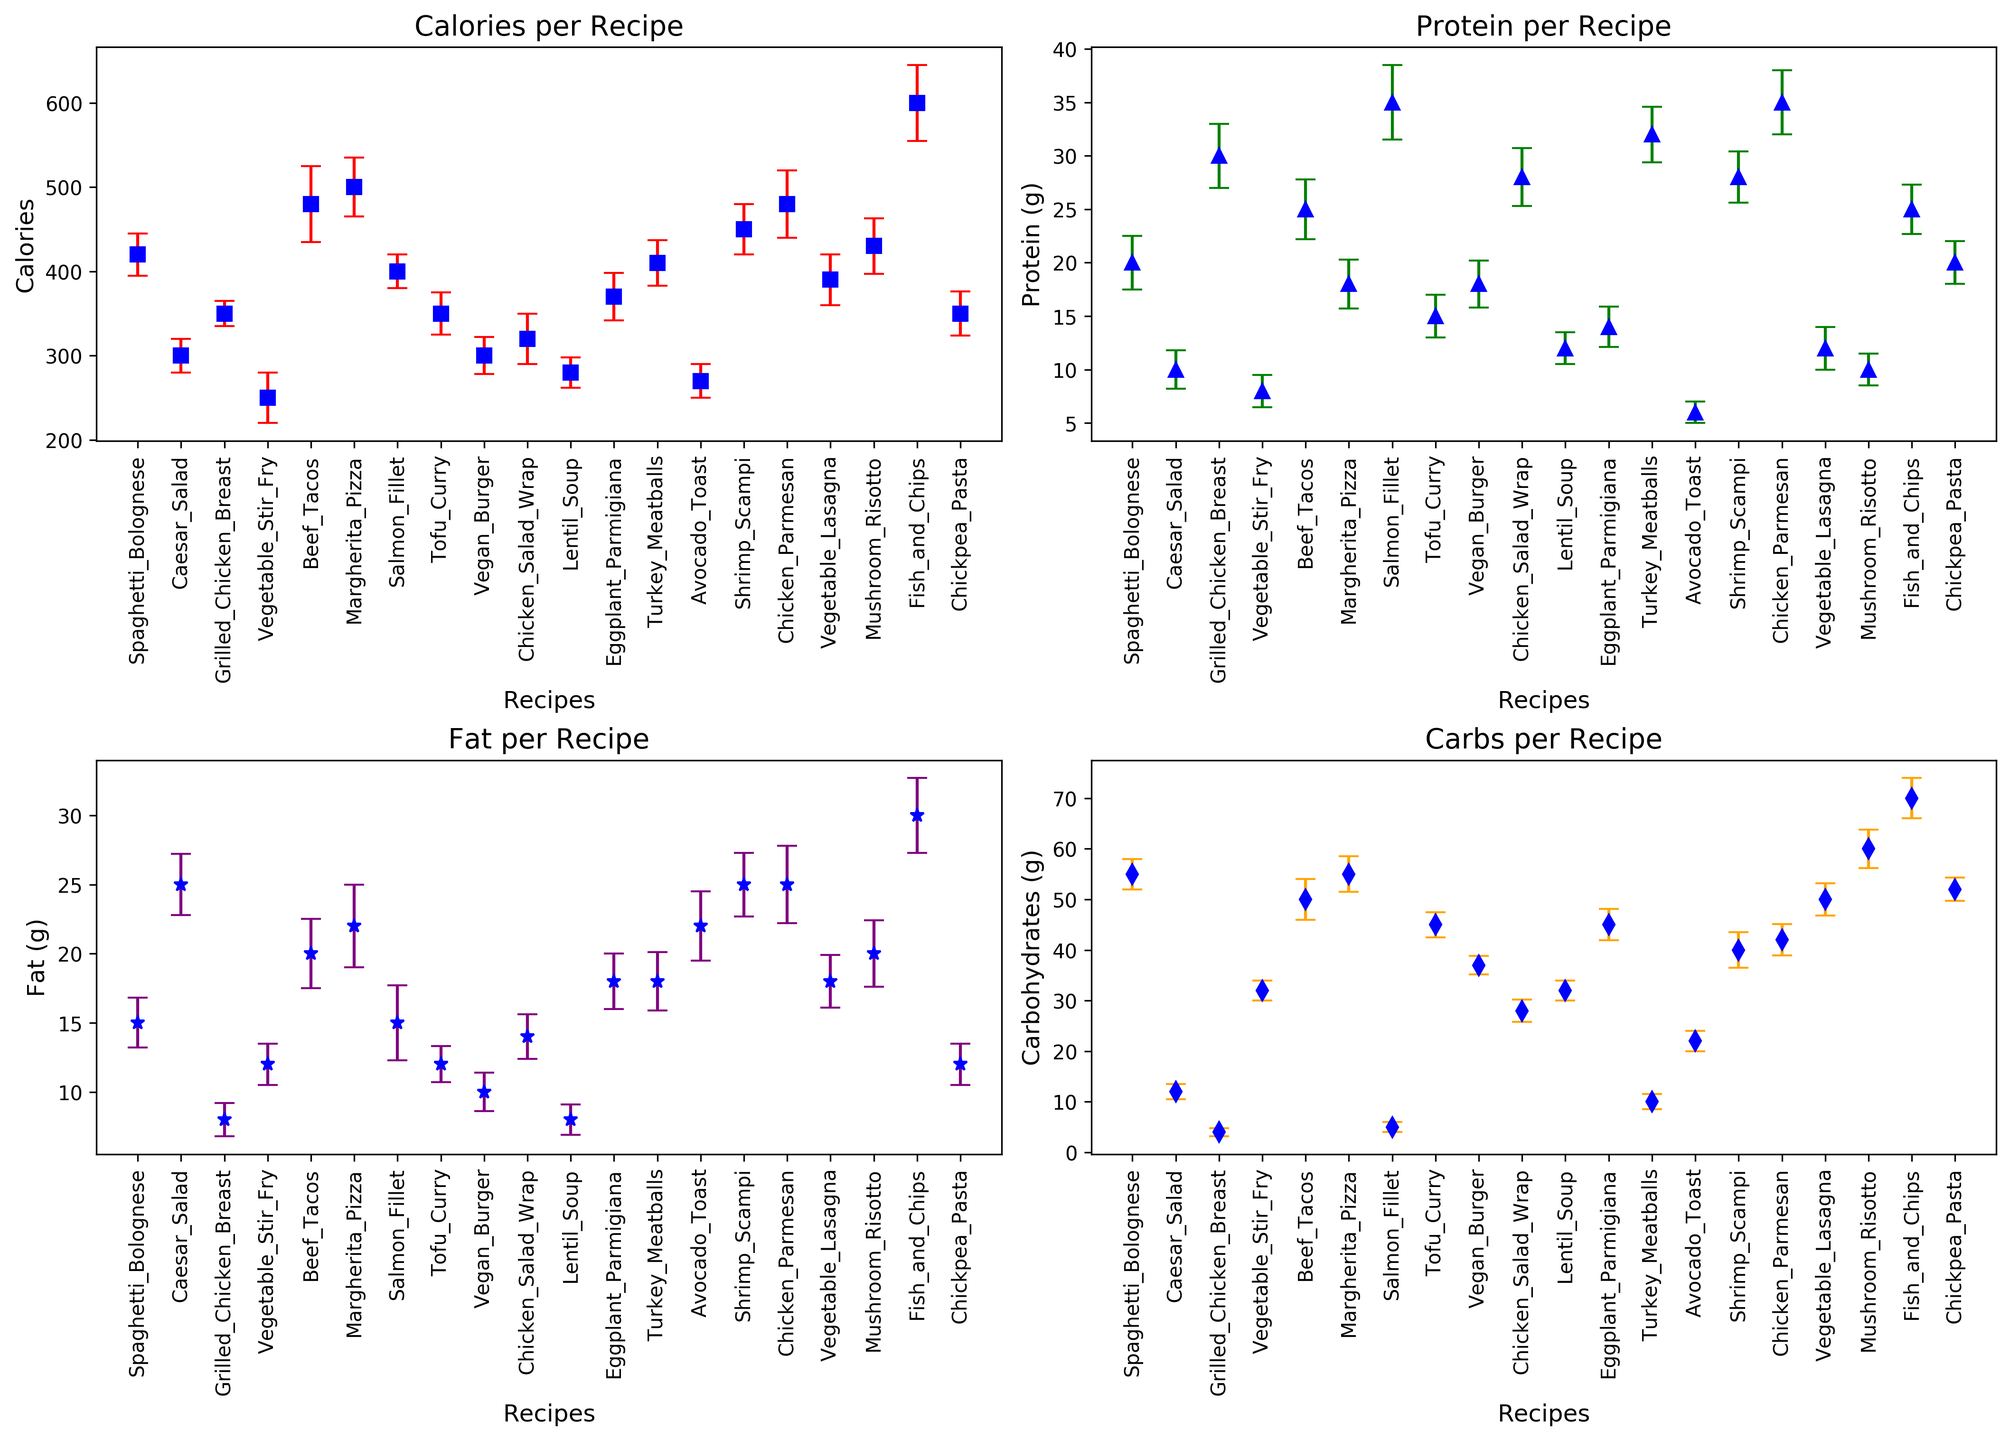What's the average difference in calories between the recipe with the highest mean calories and the recipe with the lowest mean calories? Identify the recipes with the highest and lowest mean calories from the figure. The highest mean calories is "Fish and Chips" with 600 calories, and the lowest is "Avocado Toast" with 270 calories. The difference is 600 - 270 = 330.
Answer: 330 Which recipe has more protein on average, Chicken Parmesan or Salmon Fillet? Locate "Chicken Parmesan" and "Salmon Fillet" on the protein graph. "Chicken Parmesan" has a mean protein of 35g, while "Salmon Fillet" has a mean protein of 35g. Since both are the same, they have equal protein.
Answer: Same Which recipe shows the highest variability in fat? Look at the error bars and their lengths on the fat graph. The recipe with the longest error bar indicates the highest variability. "Fish and Chips" shows the highest variability in fat with a standard deviation of 2.7g.
Answer: Fish and Chips What is the mean carbohydrate content of the Vegetable Lasagna compared to Beef Tacos? Find "Vegetable Lasagna" and "Beef Tacos" on the carbohydrate graph. "Vegetable Lasagna" has a mean of 50g, while "Beef Tacos" has a mean of 50g. Both have the same mean carbohydrate content.
Answer: Same Between the Caesar Salad and the Vegan Burger, which has a lower mean fat content? Identify the mean fat content of "Caesar Salad" and "Vegan Burger" from the fat graph. "Vegan Burger" has a mean fat content of 10g and "Caesar Salad" has 25g. "Vegan Burger" has the lower mean fat content.
Answer: Vegan Burger Is Tofu Curry higher or lower in protein compared to Lentil Soup? Find "Tofu Curry" and "Lentil Soup" on the protein graph. "Tofu Curry" has a mean protein content of 15g while "Lentil Soup" has 12g indicating that Tofu Curry is higher in protein than Lentil Soup.
Answer: Higher What is the mean difference in carbohydrates between Margherita Pizza and Mushroom Risotto? Locate "Margherita Pizza" and "Mushroom Risotto" on the carbohydrate graph and find their mean values. "Margherita Pizza" has 55g of carbohydrates and "Mushroom Risotto" has 60g. The difference is 60 - 55 = 5.
Answer: 5 Which recipes have the closest mean protein content? Examine the error bars on the protein graph and find pairs of recipes with overlapping or nearly identical mean protein values. "Tofu Curry" and "Caesar Salad" have mean protein contents very close to each other, both being 15g and 10g respectively.
Answer: Tofu Curry and Caesar Salad What is the mean fat content of Grilled Chicken Breast compared to Chicken Salad Wrap? On the fat graph, "Grilled Chicken Breast" has a mean fat content of 8g and "Chicken Salad Wrap" has a mean fat content of 14g, indicating that "Chicken Salad Wrap" has higher fat content.
Answer: Chicken Salad Wrap Which recipe has the highest mean calorie content and what is its value? Identify the recipe with the highest mean calories from the calorie chart. "Fish and Chips" has the highest mean calories at 600.
Answer: Fish and Chips, 600 